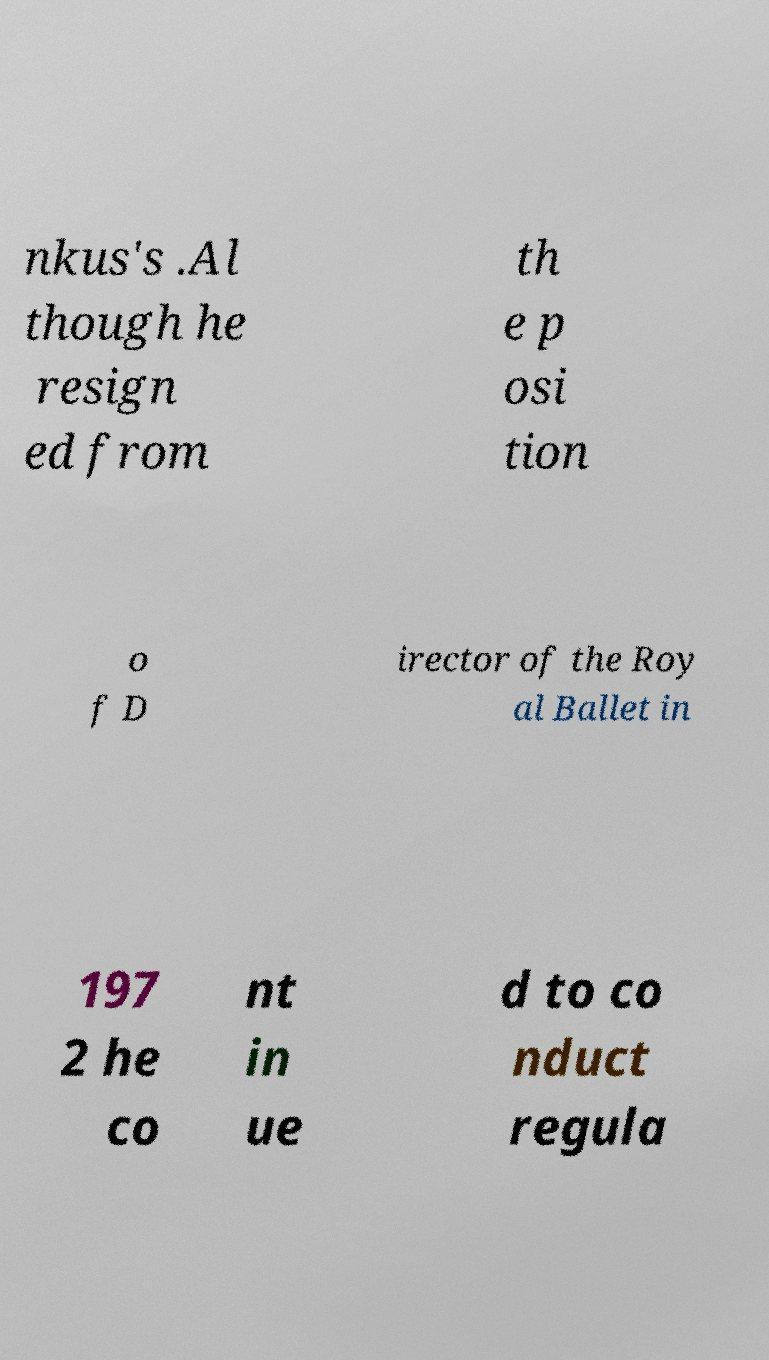Could you extract and type out the text from this image? nkus's .Al though he resign ed from th e p osi tion o f D irector of the Roy al Ballet in 197 2 he co nt in ue d to co nduct regula 